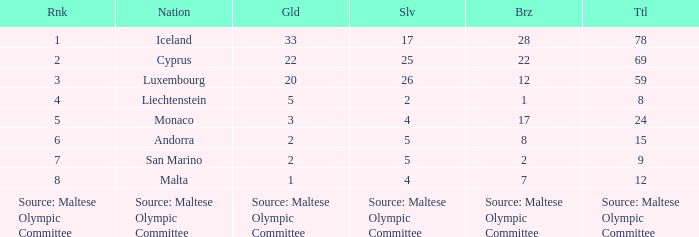What country is the owner of 28 bronze medals? Iceland. 